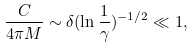<formula> <loc_0><loc_0><loc_500><loc_500>\frac { C } { 4 \pi M } \sim \delta ( \ln \frac { 1 } { \gamma } ) ^ { - 1 / 2 } \ll 1 ,</formula> 